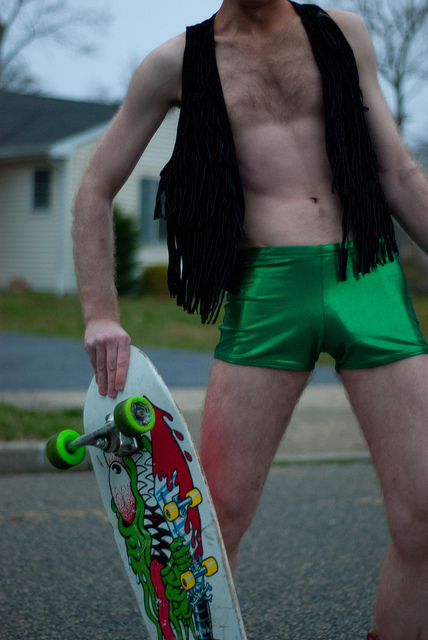<image>What animal is painted on the skateboard? I don't know what animal is painted on the skateboard. It could be an octopus, alligator, parrot, lizard, or crocodile. Why would the man put bananas in his suit? It is unknown why the man would put bananas in his suit. It could be for a costume, for fun, or to make it look bigger. What animal is painted on the skateboard? I am not sure what animal is painted on the skateboard. It can be seen as an octopus, alligator, parrot, lizard, monster or crocodile. Why would the man put bananas in his suit? I don't know why the man would put bananas in his suit. It could be for a larger package or to make himself look bigger. It could also be for a costume or just for fun. 